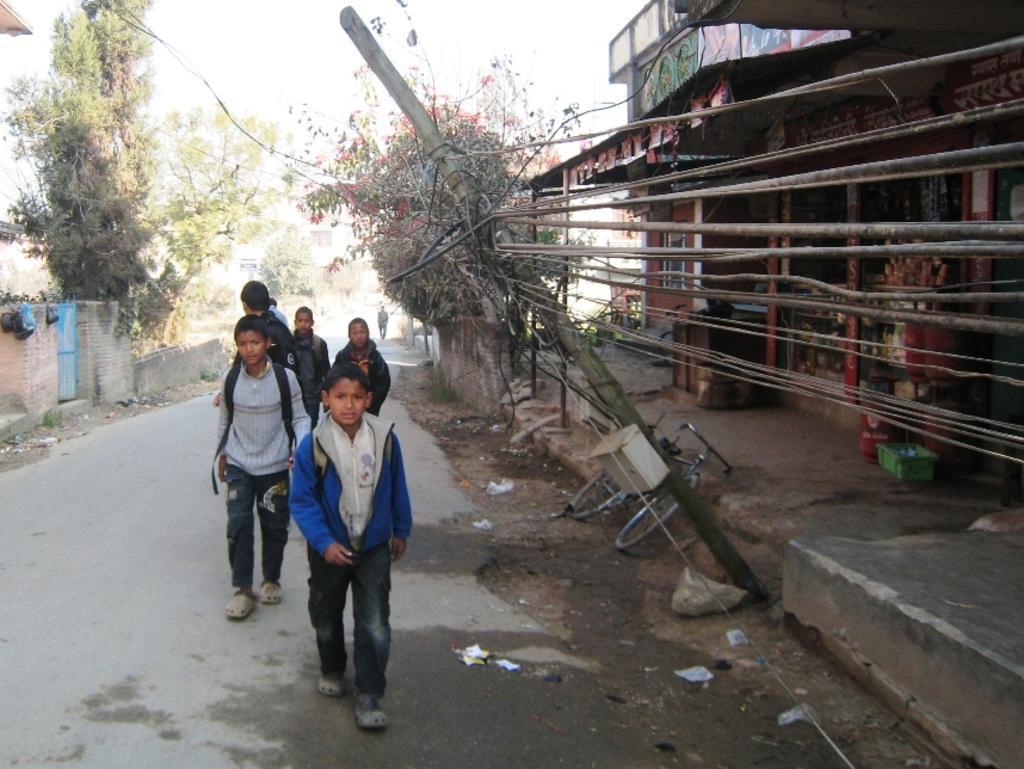Could you give a brief overview of what you see in this image? This is an outside view. On the left side there are few children wearing bags and walking on the road. Beside the road there is a pole along with the wires and also there is a bicycle. On both sides of the road, I can see the houses and trees. At the top of the image I can see the sky. 